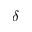Convert formula to latex. <formula><loc_0><loc_0><loc_500><loc_500>\delta</formula> 